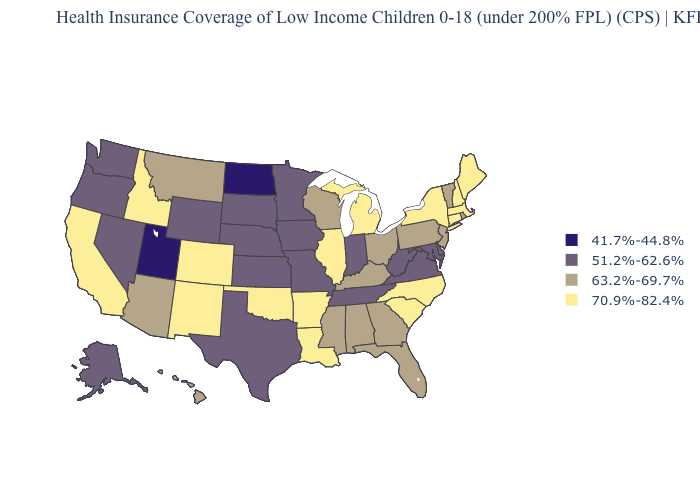What is the value of South Dakota?
Be succinct. 51.2%-62.6%. Does Ohio have the same value as Arizona?
Quick response, please. Yes. Name the states that have a value in the range 70.9%-82.4%?
Concise answer only. Arkansas, California, Colorado, Connecticut, Idaho, Illinois, Louisiana, Maine, Massachusetts, Michigan, New Hampshire, New Mexico, New York, North Carolina, Oklahoma, South Carolina. What is the value of Mississippi?
Be succinct. 63.2%-69.7%. How many symbols are there in the legend?
Give a very brief answer. 4. What is the value of North Carolina?
Write a very short answer. 70.9%-82.4%. Among the states that border California , does Oregon have the lowest value?
Keep it brief. Yes. Name the states that have a value in the range 70.9%-82.4%?
Concise answer only. Arkansas, California, Colorado, Connecticut, Idaho, Illinois, Louisiana, Maine, Massachusetts, Michigan, New Hampshire, New Mexico, New York, North Carolina, Oklahoma, South Carolina. Does the first symbol in the legend represent the smallest category?
Short answer required. Yes. What is the value of Washington?
Answer briefly. 51.2%-62.6%. Name the states that have a value in the range 51.2%-62.6%?
Concise answer only. Alaska, Delaware, Indiana, Iowa, Kansas, Maryland, Minnesota, Missouri, Nebraska, Nevada, Oregon, South Dakota, Tennessee, Texas, Virginia, Washington, West Virginia, Wyoming. Is the legend a continuous bar?
Keep it brief. No. Does Utah have the lowest value in the USA?
Give a very brief answer. Yes. What is the value of Arkansas?
Short answer required. 70.9%-82.4%. Which states have the lowest value in the USA?
Give a very brief answer. North Dakota, Utah. 